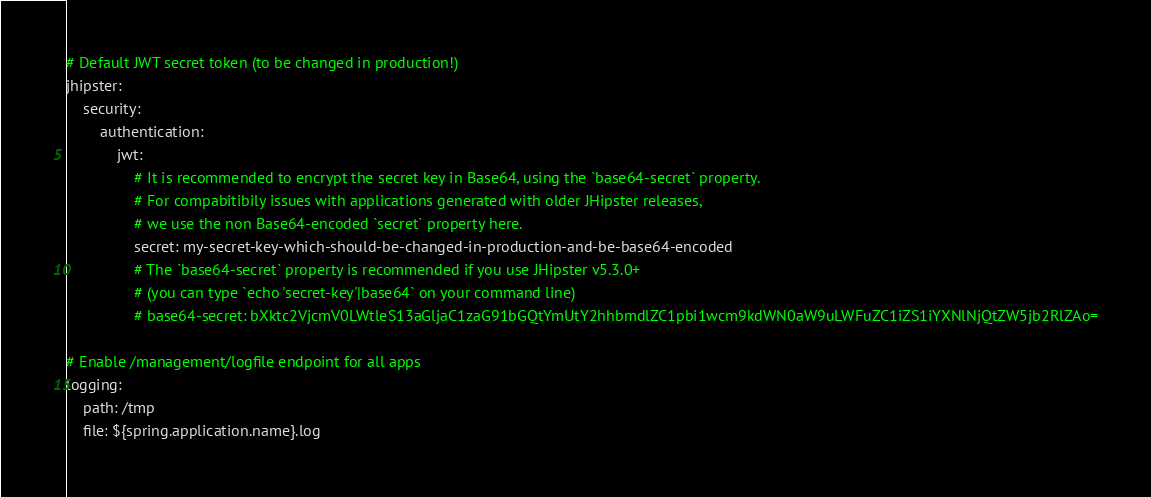<code> <loc_0><loc_0><loc_500><loc_500><_YAML_>
# Default JWT secret token (to be changed in production!)
jhipster:
    security:
        authentication:
            jwt:
                # It is recommended to encrypt the secret key in Base64, using the `base64-secret` property.
                # For compabitibily issues with applications generated with older JHipster releases,
                # we use the non Base64-encoded `secret` property here.
                secret: my-secret-key-which-should-be-changed-in-production-and-be-base64-encoded
                # The `base64-secret` property is recommended if you use JHipster v5.3.0+
                # (you can type `echo 'secret-key'|base64` on your command line)
                # base64-secret: bXktc2VjcmV0LWtleS13aGljaC1zaG91bGQtYmUtY2hhbmdlZC1pbi1wcm9kdWN0aW9uLWFuZC1iZS1iYXNlNjQtZW5jb2RlZAo=
   
# Enable /management/logfile endpoint for all apps
logging:
    path: /tmp
    file: ${spring.application.name}.log
</code> 